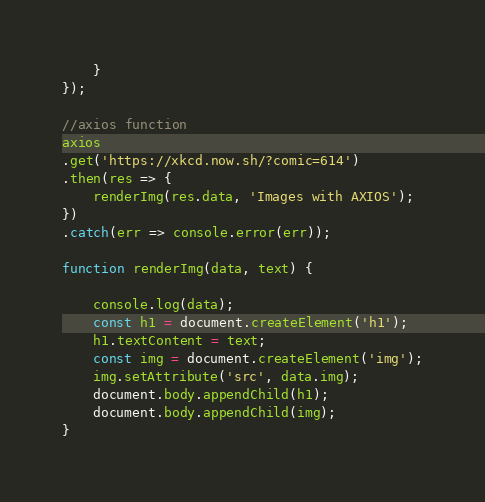<code> <loc_0><loc_0><loc_500><loc_500><_JavaScript_>    }
});

//axios function
axios
.get('https://xkcd.now.sh/?comic=614')
.then(res => {
    renderImg(res.data, 'Images with AXIOS');
})
.catch(err => console.error(err));

function renderImg(data, text) {

    console.log(data);
    const h1 = document.createElement('h1');
    h1.textContent = text;
    const img = document.createElement('img');
    img.setAttribute('src', data.img);
    document.body.appendChild(h1);
    document.body.appendChild(img);
} </code> 